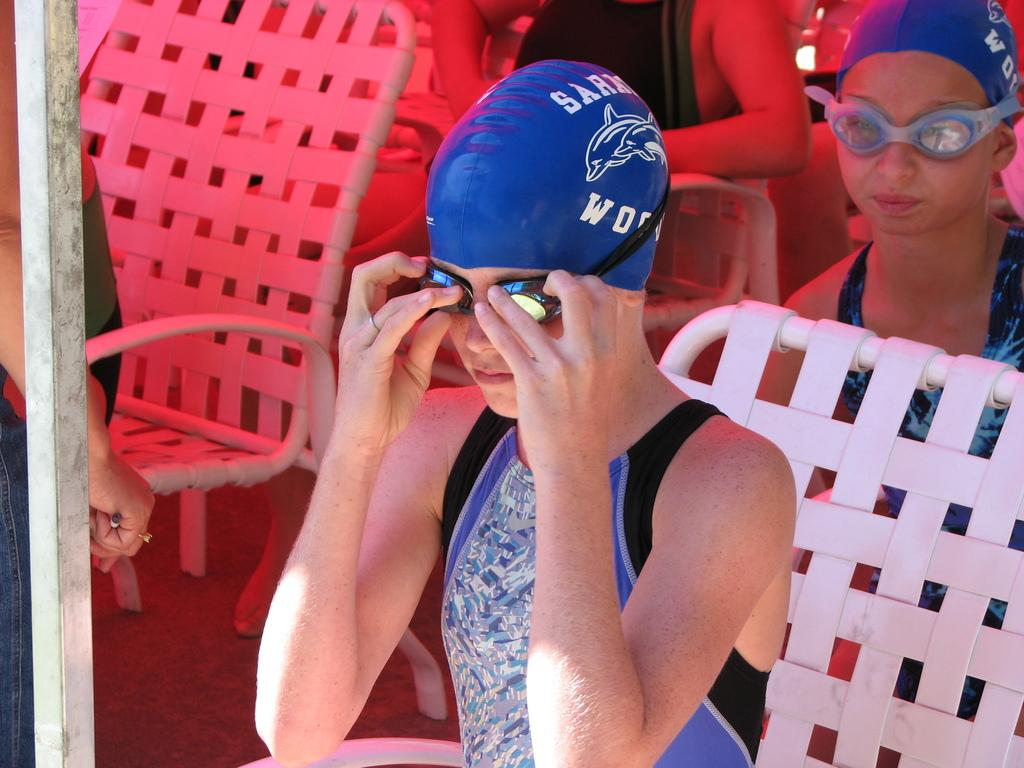How many people are sitting in the image? There are three persons sitting on chairs in the image. What can be seen on the left side of the image? There is a pole on the left side of the image. Is there anyone near the pole? Yes, there is a person standing near the pole. What type of coal is being exchanged between the units in the image? There is no coal or exchange of any kind present in the image. 